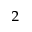Convert formula to latex. <formula><loc_0><loc_0><loc_500><loc_500>_ { 2 }</formula> 